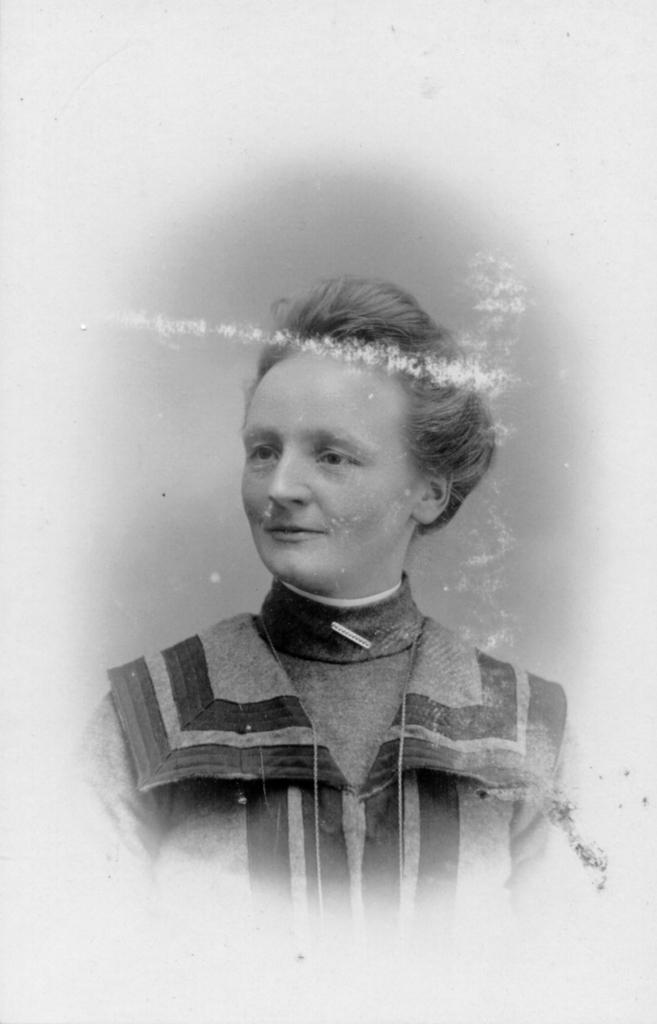Who or what is the main subject in the image? There is a person in the image. What is the person wearing? The person is wearing a shirt. How would you describe the background of the image? The background of the image is gray. What is the color of the background outside the image? The background outside the image is white. What type of silk material is being used by the person's aunt in the image? There is no mention of silk or an aunt in the image, so we cannot answer this question. 